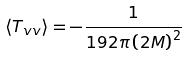<formula> <loc_0><loc_0><loc_500><loc_500>\langle T _ { v v } \rangle = - \frac { 1 } { 1 9 2 \pi \left ( 2 M \right ) ^ { 2 } }</formula> 